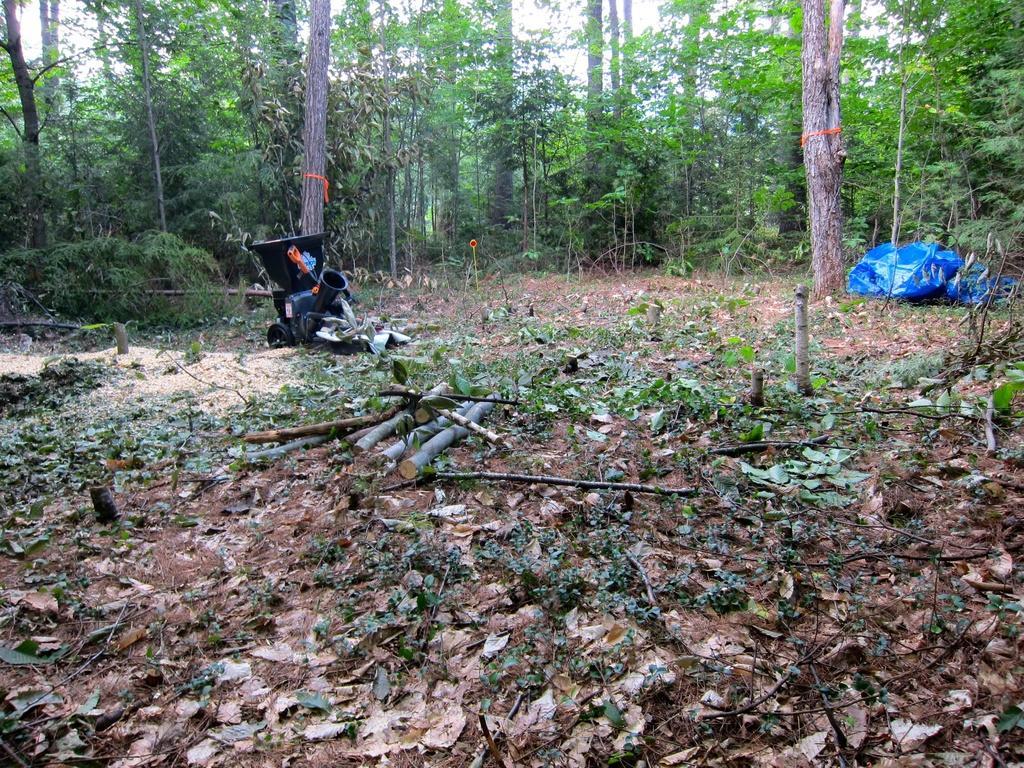How would you summarize this image in a sentence or two? In this image I see the ground on which there are leaves and I see wooden sticks over here and I see the blue color thing over here and I see an equipment over here and in the background I see number of trees. 